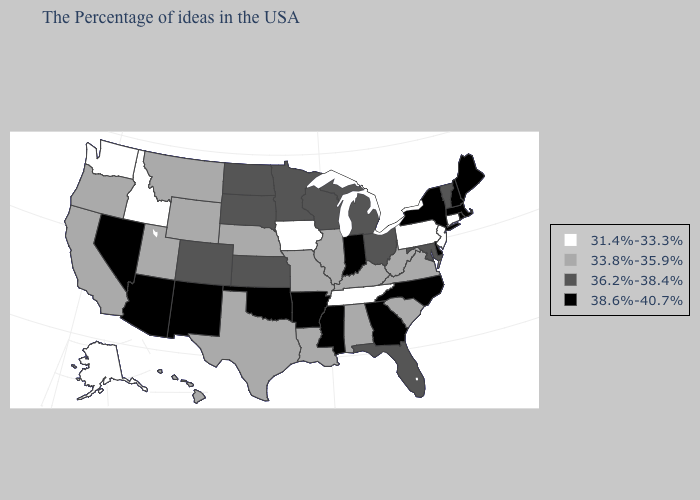Among the states that border Alabama , which have the lowest value?
Be succinct. Tennessee. Name the states that have a value in the range 38.6%-40.7%?
Concise answer only. Maine, Massachusetts, Rhode Island, New Hampshire, New York, Delaware, North Carolina, Georgia, Indiana, Mississippi, Arkansas, Oklahoma, New Mexico, Arizona, Nevada. Name the states that have a value in the range 31.4%-33.3%?
Give a very brief answer. Connecticut, New Jersey, Pennsylvania, Tennessee, Iowa, Idaho, Washington, Alaska. Does Oklahoma have a higher value than Nevada?
Quick response, please. No. Which states hav the highest value in the Northeast?
Concise answer only. Maine, Massachusetts, Rhode Island, New Hampshire, New York. Does Maryland have the same value as Ohio?
Be succinct. Yes. Which states hav the highest value in the Northeast?
Be succinct. Maine, Massachusetts, Rhode Island, New Hampshire, New York. What is the highest value in states that border Oregon?
Write a very short answer. 38.6%-40.7%. Does Texas have the highest value in the USA?
Be succinct. No. Name the states that have a value in the range 31.4%-33.3%?
Give a very brief answer. Connecticut, New Jersey, Pennsylvania, Tennessee, Iowa, Idaho, Washington, Alaska. Name the states that have a value in the range 33.8%-35.9%?
Concise answer only. Virginia, South Carolina, West Virginia, Kentucky, Alabama, Illinois, Louisiana, Missouri, Nebraska, Texas, Wyoming, Utah, Montana, California, Oregon, Hawaii. Among the states that border Vermont , which have the highest value?
Concise answer only. Massachusetts, New Hampshire, New York. Which states have the highest value in the USA?
Be succinct. Maine, Massachusetts, Rhode Island, New Hampshire, New York, Delaware, North Carolina, Georgia, Indiana, Mississippi, Arkansas, Oklahoma, New Mexico, Arizona, Nevada. Is the legend a continuous bar?
Answer briefly. No. 